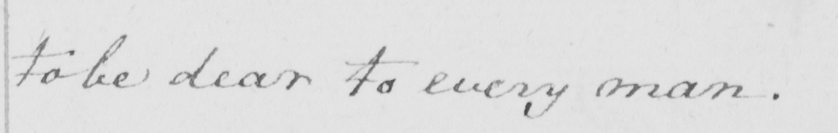Can you tell me what this handwritten text says? to be dear to every man. 